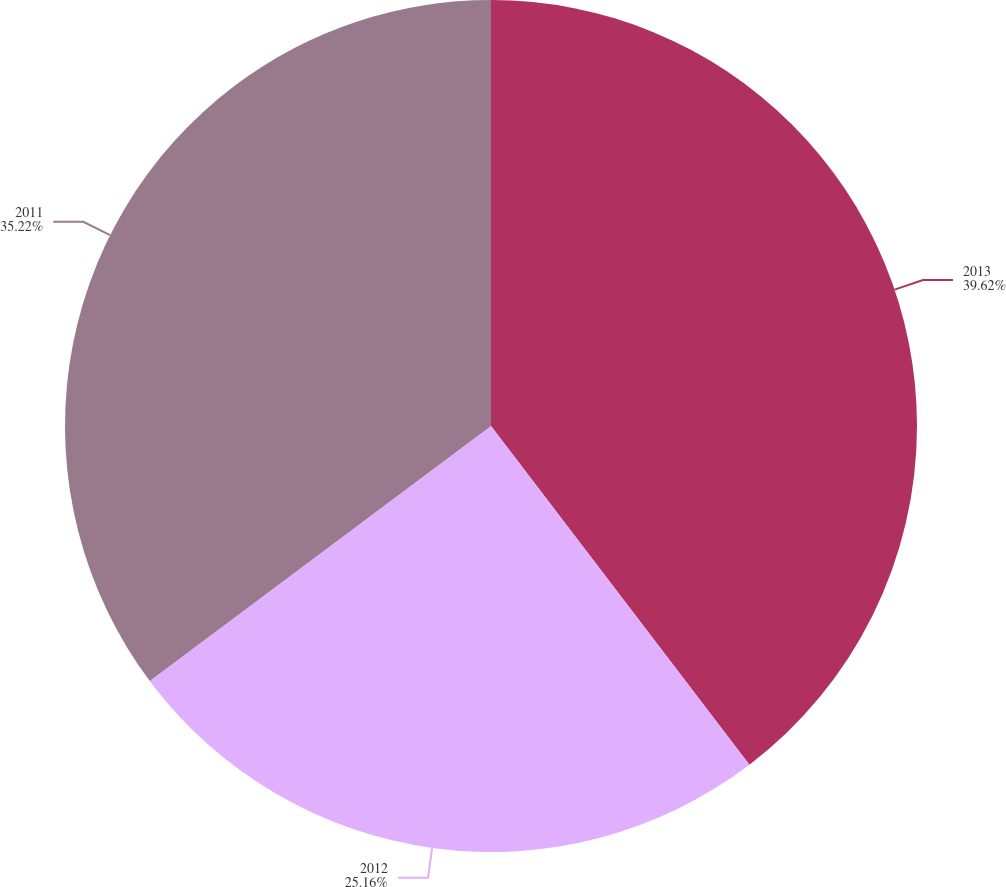<chart> <loc_0><loc_0><loc_500><loc_500><pie_chart><fcel>2013<fcel>2012<fcel>2011<nl><fcel>39.63%<fcel>25.16%<fcel>35.22%<nl></chart> 